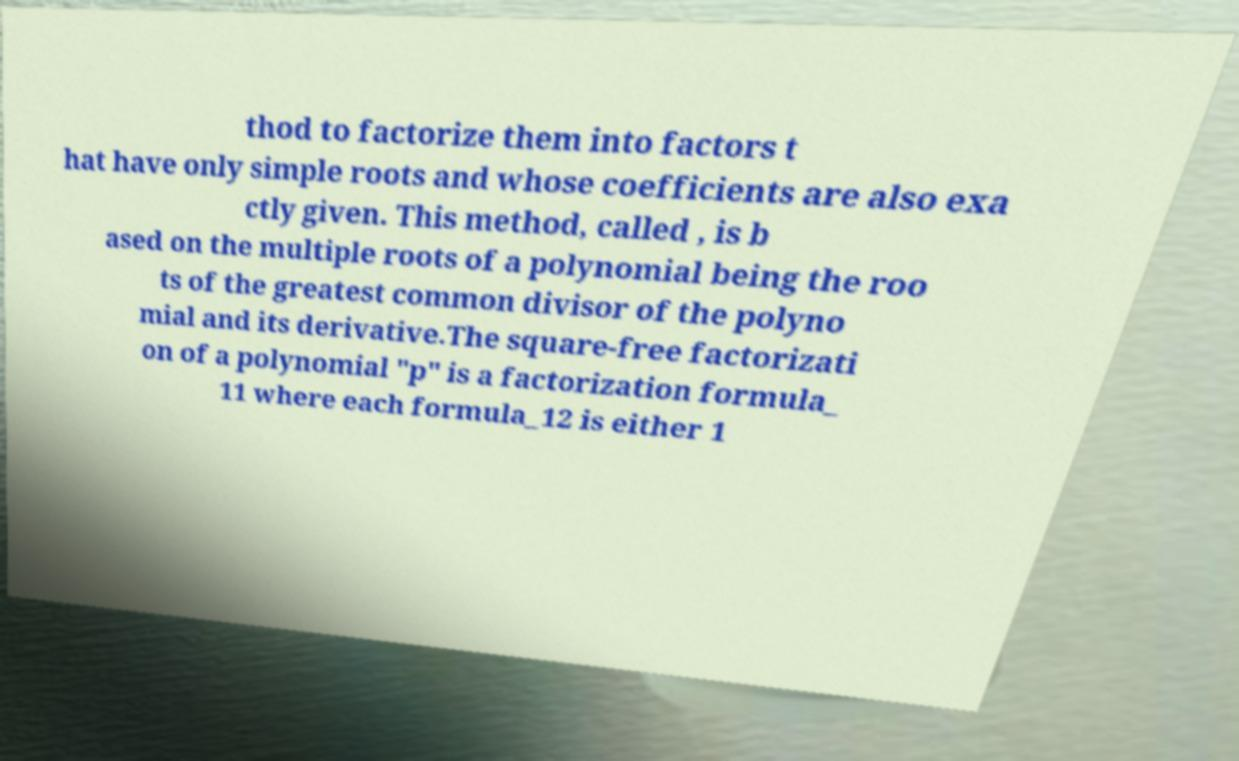Can you read and provide the text displayed in the image?This photo seems to have some interesting text. Can you extract and type it out for me? thod to factorize them into factors t hat have only simple roots and whose coefficients are also exa ctly given. This method, called , is b ased on the multiple roots of a polynomial being the roo ts of the greatest common divisor of the polyno mial and its derivative.The square-free factorizati on of a polynomial "p" is a factorization formula_ 11 where each formula_12 is either 1 